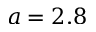Convert formula to latex. <formula><loc_0><loc_0><loc_500><loc_500>a = 2 . 8</formula> 